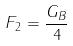<formula> <loc_0><loc_0><loc_500><loc_500>F _ { 2 } = \frac { G _ { B } } { 4 }</formula> 